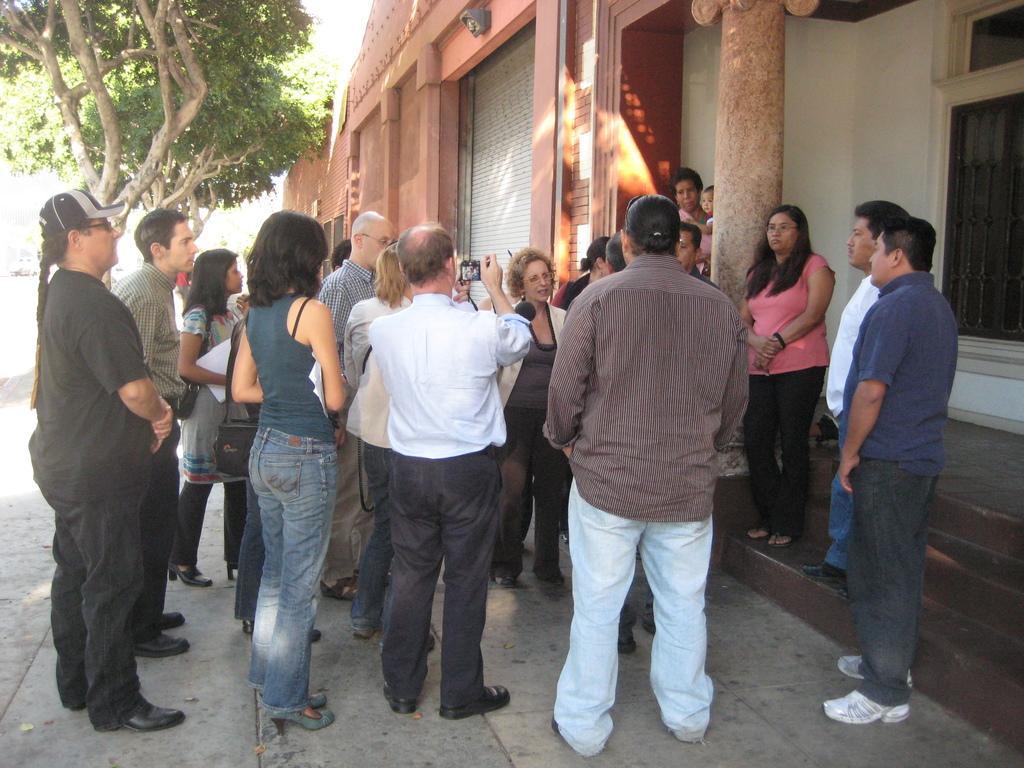Can you describe this image briefly? Here a group of people are standing, on the left side there are green trees and this is the house. 